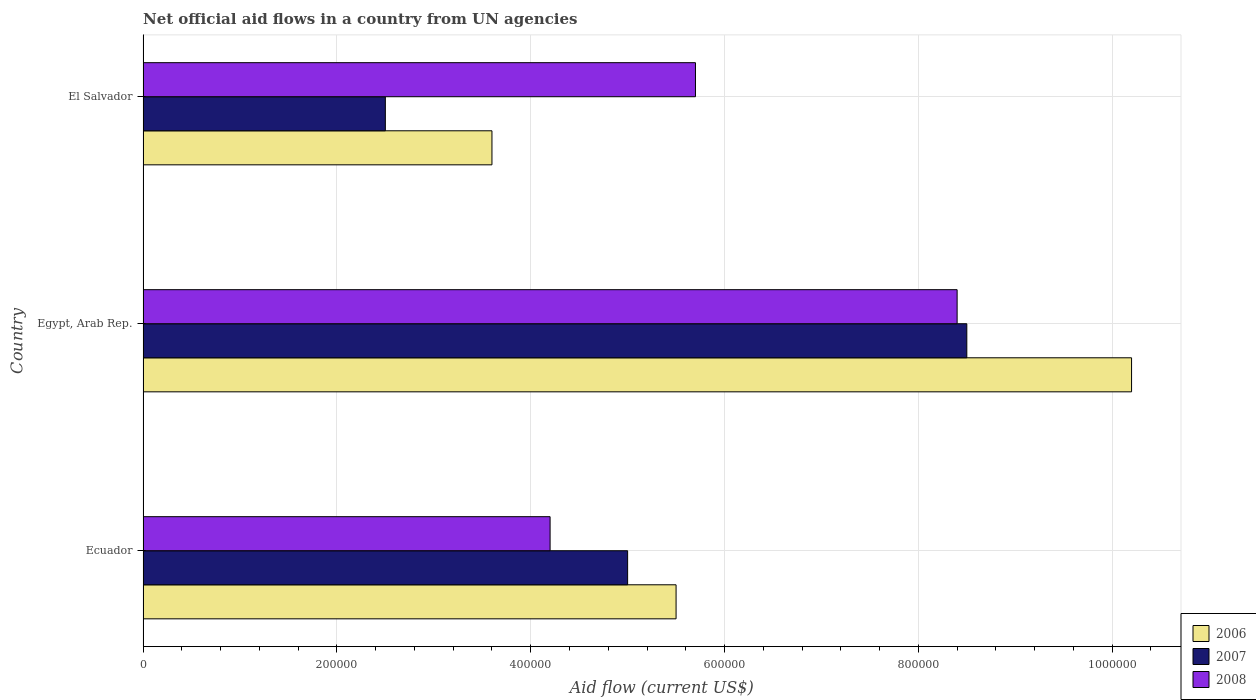How many different coloured bars are there?
Offer a terse response. 3. How many groups of bars are there?
Keep it short and to the point. 3. Are the number of bars per tick equal to the number of legend labels?
Your answer should be compact. Yes. How many bars are there on the 2nd tick from the top?
Provide a short and direct response. 3. What is the label of the 1st group of bars from the top?
Provide a succinct answer. El Salvador. In how many cases, is the number of bars for a given country not equal to the number of legend labels?
Your answer should be very brief. 0. Across all countries, what is the maximum net official aid flow in 2006?
Make the answer very short. 1.02e+06. In which country was the net official aid flow in 2007 maximum?
Provide a short and direct response. Egypt, Arab Rep. In which country was the net official aid flow in 2008 minimum?
Provide a short and direct response. Ecuador. What is the total net official aid flow in 2008 in the graph?
Provide a succinct answer. 1.83e+06. What is the difference between the net official aid flow in 2008 in Ecuador and that in El Salvador?
Offer a very short reply. -1.50e+05. What is the average net official aid flow in 2006 per country?
Offer a terse response. 6.43e+05. Is the net official aid flow in 2008 in Ecuador less than that in El Salvador?
Offer a very short reply. Yes. Is the difference between the net official aid flow in 2006 in Egypt, Arab Rep. and El Salvador greater than the difference between the net official aid flow in 2008 in Egypt, Arab Rep. and El Salvador?
Your answer should be very brief. Yes. Is the sum of the net official aid flow in 2007 in Ecuador and Egypt, Arab Rep. greater than the maximum net official aid flow in 2006 across all countries?
Provide a succinct answer. Yes. Is it the case that in every country, the sum of the net official aid flow in 2006 and net official aid flow in 2008 is greater than the net official aid flow in 2007?
Offer a very short reply. Yes. How many bars are there?
Your answer should be very brief. 9. What is the difference between two consecutive major ticks on the X-axis?
Your answer should be very brief. 2.00e+05. Are the values on the major ticks of X-axis written in scientific E-notation?
Make the answer very short. No. Where does the legend appear in the graph?
Provide a short and direct response. Bottom right. How many legend labels are there?
Provide a short and direct response. 3. What is the title of the graph?
Offer a terse response. Net official aid flows in a country from UN agencies. Does "1969" appear as one of the legend labels in the graph?
Your response must be concise. No. What is the Aid flow (current US$) of 2007 in Ecuador?
Your answer should be very brief. 5.00e+05. What is the Aid flow (current US$) of 2008 in Ecuador?
Give a very brief answer. 4.20e+05. What is the Aid flow (current US$) of 2006 in Egypt, Arab Rep.?
Offer a very short reply. 1.02e+06. What is the Aid flow (current US$) of 2007 in Egypt, Arab Rep.?
Ensure brevity in your answer.  8.50e+05. What is the Aid flow (current US$) of 2008 in Egypt, Arab Rep.?
Provide a succinct answer. 8.40e+05. What is the Aid flow (current US$) in 2008 in El Salvador?
Provide a short and direct response. 5.70e+05. Across all countries, what is the maximum Aid flow (current US$) in 2006?
Offer a very short reply. 1.02e+06. Across all countries, what is the maximum Aid flow (current US$) of 2007?
Your response must be concise. 8.50e+05. Across all countries, what is the maximum Aid flow (current US$) of 2008?
Give a very brief answer. 8.40e+05. Across all countries, what is the minimum Aid flow (current US$) of 2006?
Keep it short and to the point. 3.60e+05. Across all countries, what is the minimum Aid flow (current US$) in 2008?
Offer a terse response. 4.20e+05. What is the total Aid flow (current US$) of 2006 in the graph?
Provide a short and direct response. 1.93e+06. What is the total Aid flow (current US$) of 2007 in the graph?
Offer a very short reply. 1.60e+06. What is the total Aid flow (current US$) of 2008 in the graph?
Offer a very short reply. 1.83e+06. What is the difference between the Aid flow (current US$) in 2006 in Ecuador and that in Egypt, Arab Rep.?
Offer a very short reply. -4.70e+05. What is the difference between the Aid flow (current US$) in 2007 in Ecuador and that in Egypt, Arab Rep.?
Your answer should be compact. -3.50e+05. What is the difference between the Aid flow (current US$) in 2008 in Ecuador and that in Egypt, Arab Rep.?
Provide a short and direct response. -4.20e+05. What is the difference between the Aid flow (current US$) in 2007 in Ecuador and that in El Salvador?
Offer a terse response. 2.50e+05. What is the difference between the Aid flow (current US$) in 2008 in Ecuador and that in El Salvador?
Offer a terse response. -1.50e+05. What is the difference between the Aid flow (current US$) in 2006 in Egypt, Arab Rep. and that in El Salvador?
Provide a short and direct response. 6.60e+05. What is the difference between the Aid flow (current US$) of 2007 in Egypt, Arab Rep. and that in El Salvador?
Your answer should be very brief. 6.00e+05. What is the difference between the Aid flow (current US$) of 2008 in Egypt, Arab Rep. and that in El Salvador?
Give a very brief answer. 2.70e+05. What is the difference between the Aid flow (current US$) in 2006 in Ecuador and the Aid flow (current US$) in 2007 in Egypt, Arab Rep.?
Provide a short and direct response. -3.00e+05. What is the difference between the Aid flow (current US$) of 2007 in Ecuador and the Aid flow (current US$) of 2008 in Egypt, Arab Rep.?
Provide a short and direct response. -3.40e+05. What is the difference between the Aid flow (current US$) of 2006 in Ecuador and the Aid flow (current US$) of 2007 in El Salvador?
Your response must be concise. 3.00e+05. What is the difference between the Aid flow (current US$) in 2006 in Ecuador and the Aid flow (current US$) in 2008 in El Salvador?
Offer a very short reply. -2.00e+04. What is the difference between the Aid flow (current US$) of 2006 in Egypt, Arab Rep. and the Aid flow (current US$) of 2007 in El Salvador?
Ensure brevity in your answer.  7.70e+05. What is the difference between the Aid flow (current US$) in 2006 in Egypt, Arab Rep. and the Aid flow (current US$) in 2008 in El Salvador?
Give a very brief answer. 4.50e+05. What is the difference between the Aid flow (current US$) in 2007 in Egypt, Arab Rep. and the Aid flow (current US$) in 2008 in El Salvador?
Offer a terse response. 2.80e+05. What is the average Aid flow (current US$) in 2006 per country?
Provide a short and direct response. 6.43e+05. What is the average Aid flow (current US$) in 2007 per country?
Make the answer very short. 5.33e+05. What is the difference between the Aid flow (current US$) of 2006 and Aid flow (current US$) of 2007 in Egypt, Arab Rep.?
Your answer should be compact. 1.70e+05. What is the difference between the Aid flow (current US$) in 2006 and Aid flow (current US$) in 2008 in Egypt, Arab Rep.?
Give a very brief answer. 1.80e+05. What is the difference between the Aid flow (current US$) of 2007 and Aid flow (current US$) of 2008 in Egypt, Arab Rep.?
Give a very brief answer. 10000. What is the difference between the Aid flow (current US$) of 2007 and Aid flow (current US$) of 2008 in El Salvador?
Provide a succinct answer. -3.20e+05. What is the ratio of the Aid flow (current US$) of 2006 in Ecuador to that in Egypt, Arab Rep.?
Keep it short and to the point. 0.54. What is the ratio of the Aid flow (current US$) of 2007 in Ecuador to that in Egypt, Arab Rep.?
Provide a succinct answer. 0.59. What is the ratio of the Aid flow (current US$) of 2006 in Ecuador to that in El Salvador?
Your answer should be compact. 1.53. What is the ratio of the Aid flow (current US$) of 2007 in Ecuador to that in El Salvador?
Your response must be concise. 2. What is the ratio of the Aid flow (current US$) in 2008 in Ecuador to that in El Salvador?
Offer a terse response. 0.74. What is the ratio of the Aid flow (current US$) of 2006 in Egypt, Arab Rep. to that in El Salvador?
Your answer should be very brief. 2.83. What is the ratio of the Aid flow (current US$) of 2007 in Egypt, Arab Rep. to that in El Salvador?
Your response must be concise. 3.4. What is the ratio of the Aid flow (current US$) of 2008 in Egypt, Arab Rep. to that in El Salvador?
Keep it short and to the point. 1.47. What is the difference between the highest and the second highest Aid flow (current US$) in 2007?
Keep it short and to the point. 3.50e+05. What is the difference between the highest and the second highest Aid flow (current US$) of 2008?
Provide a succinct answer. 2.70e+05. What is the difference between the highest and the lowest Aid flow (current US$) of 2006?
Give a very brief answer. 6.60e+05. What is the difference between the highest and the lowest Aid flow (current US$) in 2007?
Provide a succinct answer. 6.00e+05. 